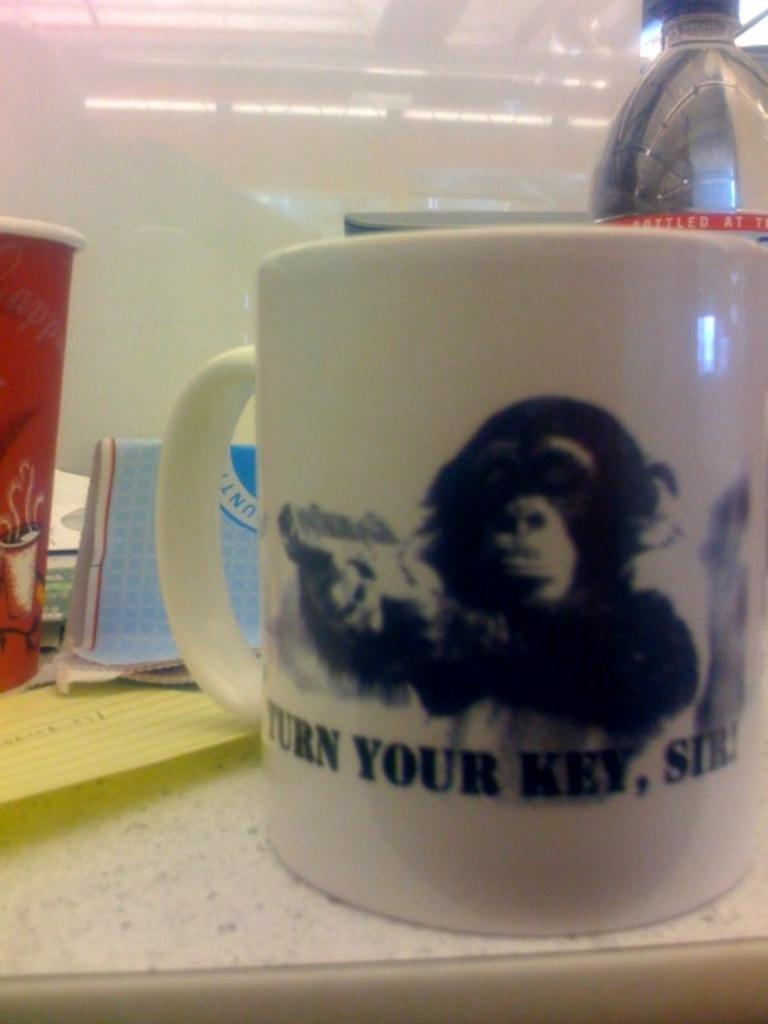Provide a one-sentence caption for the provided image. A mug with a monkey on it says turn your key, sir. 